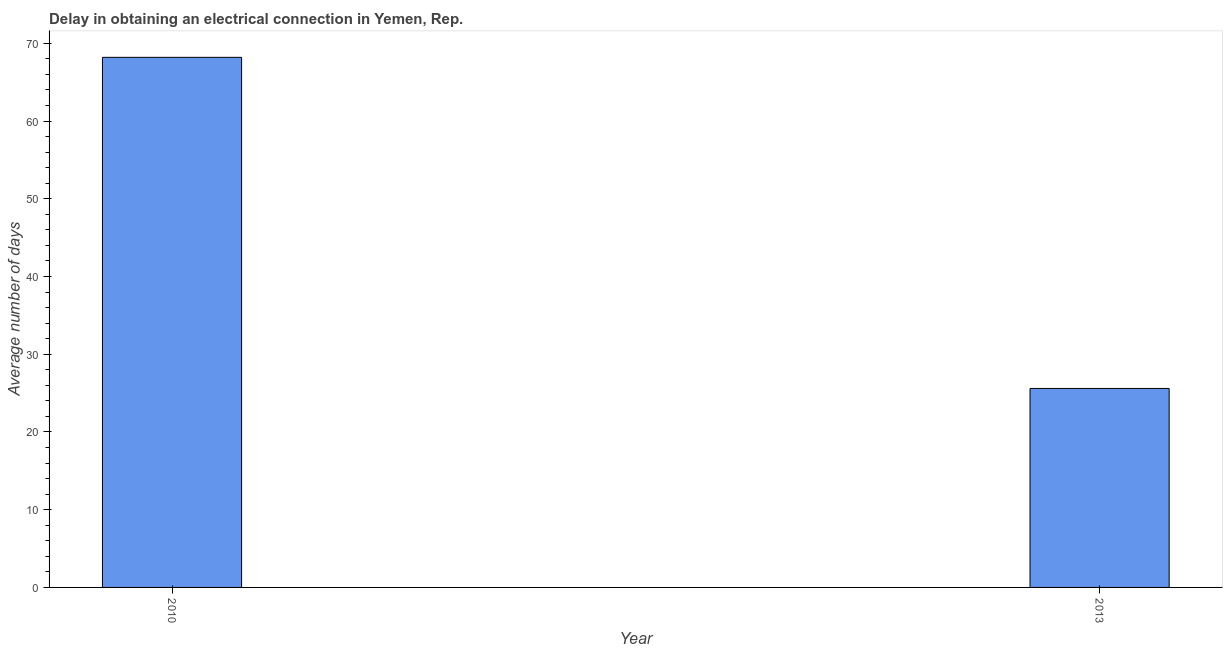Does the graph contain any zero values?
Offer a very short reply. No. Does the graph contain grids?
Give a very brief answer. No. What is the title of the graph?
Make the answer very short. Delay in obtaining an electrical connection in Yemen, Rep. What is the label or title of the X-axis?
Provide a short and direct response. Year. What is the label or title of the Y-axis?
Provide a short and direct response. Average number of days. What is the dalay in electrical connection in 2013?
Keep it short and to the point. 25.6. Across all years, what is the maximum dalay in electrical connection?
Your answer should be very brief. 68.2. Across all years, what is the minimum dalay in electrical connection?
Ensure brevity in your answer.  25.6. In which year was the dalay in electrical connection maximum?
Your answer should be compact. 2010. What is the sum of the dalay in electrical connection?
Offer a very short reply. 93.8. What is the difference between the dalay in electrical connection in 2010 and 2013?
Offer a terse response. 42.6. What is the average dalay in electrical connection per year?
Offer a very short reply. 46.9. What is the median dalay in electrical connection?
Provide a succinct answer. 46.9. Do a majority of the years between 2010 and 2013 (inclusive) have dalay in electrical connection greater than 40 days?
Provide a short and direct response. No. What is the ratio of the dalay in electrical connection in 2010 to that in 2013?
Offer a very short reply. 2.66. In how many years, is the dalay in electrical connection greater than the average dalay in electrical connection taken over all years?
Ensure brevity in your answer.  1. How many bars are there?
Make the answer very short. 2. How many years are there in the graph?
Your answer should be very brief. 2. What is the difference between two consecutive major ticks on the Y-axis?
Give a very brief answer. 10. What is the Average number of days of 2010?
Offer a very short reply. 68.2. What is the Average number of days in 2013?
Make the answer very short. 25.6. What is the difference between the Average number of days in 2010 and 2013?
Provide a short and direct response. 42.6. What is the ratio of the Average number of days in 2010 to that in 2013?
Your response must be concise. 2.66. 